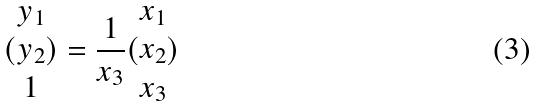<formula> <loc_0><loc_0><loc_500><loc_500>( \begin{matrix} y _ { 1 } \\ y _ { 2 } \\ 1 \end{matrix} ) = \frac { 1 } { x _ { 3 } } ( \begin{matrix} x _ { 1 } \\ x _ { 2 } \\ x _ { 3 } \end{matrix} )</formula> 